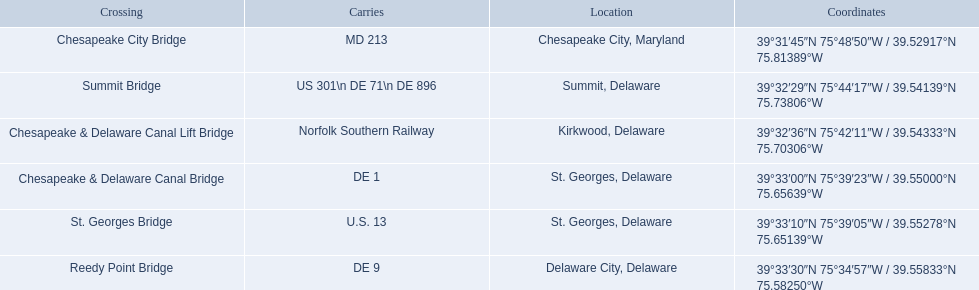What is being carried in the canal? MD 213, US 301\n DE 71\n DE 896, Norfolk Southern Railway, DE 1, U.S. 13, DE 9. Of those which has the largest number of different routes? US 301\n DE 71\n DE 896. To which crossing does that relate? Summit Bridge. Help me parse the entirety of this table. {'header': ['Crossing', 'Carries', 'Location', 'Coordinates'], 'rows': [['Chesapeake City Bridge', 'MD 213', 'Chesapeake City, Maryland', '39°31′45″N 75°48′50″W\ufeff / \ufeff39.52917°N 75.81389°W'], ['Summit Bridge', 'US 301\\n DE 71\\n DE 896', 'Summit, Delaware', '39°32′29″N 75°44′17″W\ufeff / \ufeff39.54139°N 75.73806°W'], ['Chesapeake & Delaware Canal Lift Bridge', 'Norfolk Southern Railway', 'Kirkwood, Delaware', '39°32′36″N 75°42′11″W\ufeff / \ufeff39.54333°N 75.70306°W'], ['Chesapeake & Delaware Canal Bridge', 'DE 1', 'St.\xa0Georges, Delaware', '39°33′00″N 75°39′23″W\ufeff / \ufeff39.55000°N 75.65639°W'], ['St.\xa0Georges Bridge', 'U.S.\xa013', 'St.\xa0Georges, Delaware', '39°33′10″N 75°39′05″W\ufeff / \ufeff39.55278°N 75.65139°W'], ['Reedy Point Bridge', 'DE\xa09', 'Delaware City, Delaware', '39°33′30″N 75°34′57″W\ufeff / \ufeff39.55833°N 75.58250°W']]} What are the names of the major crossings for the chesapeake and delaware canal? Chesapeake City Bridge, Summit Bridge, Chesapeake & Delaware Canal Lift Bridge, Chesapeake & Delaware Canal Bridge, St. Georges Bridge, Reedy Point Bridge. What routes are carried by these crossings? MD 213, US 301\n DE 71\n DE 896, Norfolk Southern Railway, DE 1, U.S. 13, DE 9. Which of those routes is comprised of more than one route? US 301\n DE 71\n DE 896. Which crossing carries those routes? Summit Bridge. What is transported within the canal? MD 213, US 301\n DE 71\n DE 896, Norfolk Southern Railway, DE 1, U.S. 13, DE 9. Which of those transports de 9? DE 9. To which intersection does that entrance correspond? Reedy Point Bridge. 